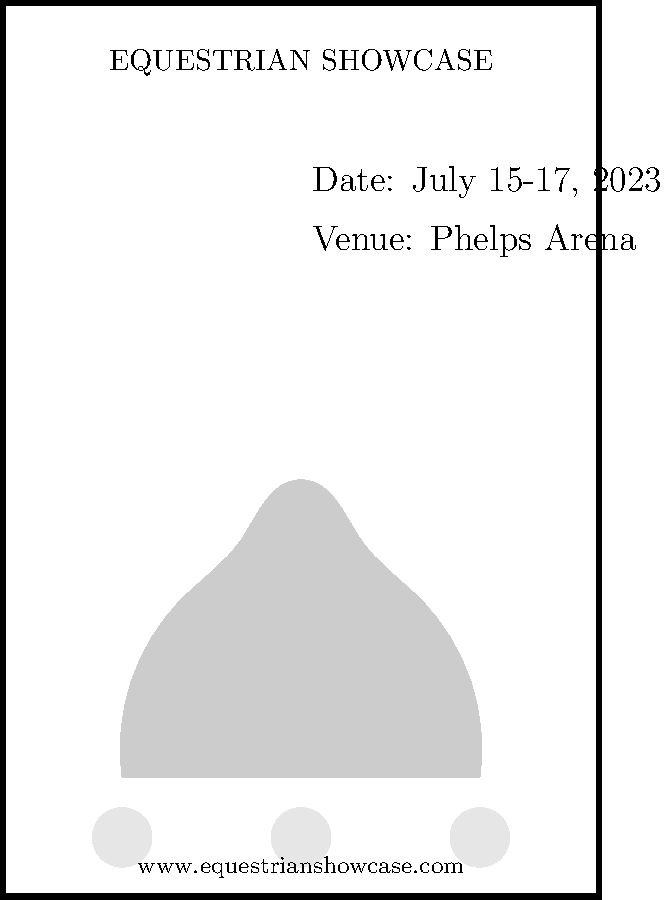Analyze the layout and design elements of this equestrian event poster. How does the composition reflect Mason Phelps Jr.'s influence on the sport, and what improvements could be made to enhance its effectiveness? 1. Overall layout: The poster uses a vertical format, typical for event announcements. This layout is efficient for displaying information and was often used in events organized by Mason Phelps Jr.

2. Title placement: "EQUESTRIAN SHOWCASE" is prominently displayed at the top, drawing immediate attention. This aligns with Phelps' emphasis on creating high-profile, attention-grabbing events.

3. Event details: Key information (date and venue) is clearly presented on the right side. The mention of "Phelps Arena" likely refers to a venue named after Mason Phelps Jr., reflecting his legacy in the sport.

4. Central image: The horse silhouette serves as the focal point, representing the essence of the event. This simple yet effective design element is reminiscent of Phelps' approach to branding equestrian events.

5. Sponsor recognition: The three circles at the bottom likely represent sponsor logos, acknowledging the importance of sponsorships in equestrian events, which Phelps was known for cultivating.

6. Contact information: The website is included at the bottom, providing a means for interested parties to find more information.

Improvements:
1. Color: The current design lacks color, which could be added to make it more visually appealing and align with Phelps' flair for showmanship.
2. Typography: Varying font styles and sizes could enhance readability and visual hierarchy.
3. Additional details: Including information about specific competitions or notable participants could generate more interest, as Phelps often did for his events.
4. Logo: Incorporating a logo for the Equestrian Showcase or Phelps Arena could strengthen brand recognition.
5. White space: Better utilization of white space could improve overall balance and readability.

These improvements would enhance the poster's effectiveness while maintaining the essence of Mason Phelps Jr.'s influence on equestrian event promotion.
Answer: The poster reflects Phelps' influence through its clear information hierarchy and sponsor recognition, but could be improved with color, varied typography, and additional event details to enhance its impact and align with his showmanship style. 